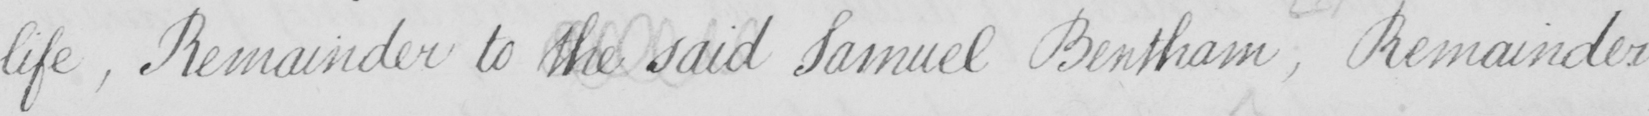What text is written in this handwritten line? life , Remainder to the said Samuel Bentham , Remainder 